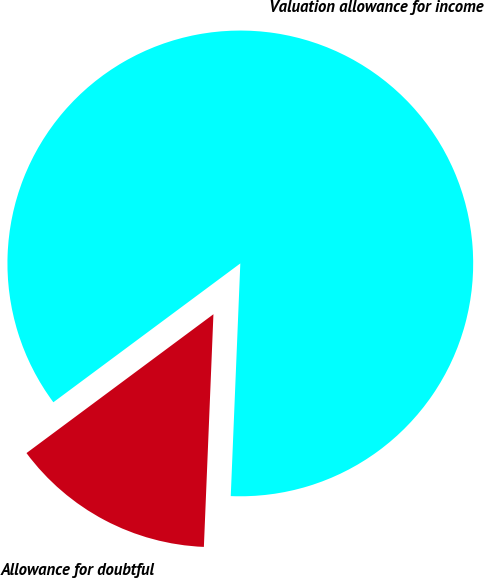<chart> <loc_0><loc_0><loc_500><loc_500><pie_chart><fcel>Allowance for doubtful<fcel>Valuation allowance for income<nl><fcel>14.18%<fcel>85.82%<nl></chart> 